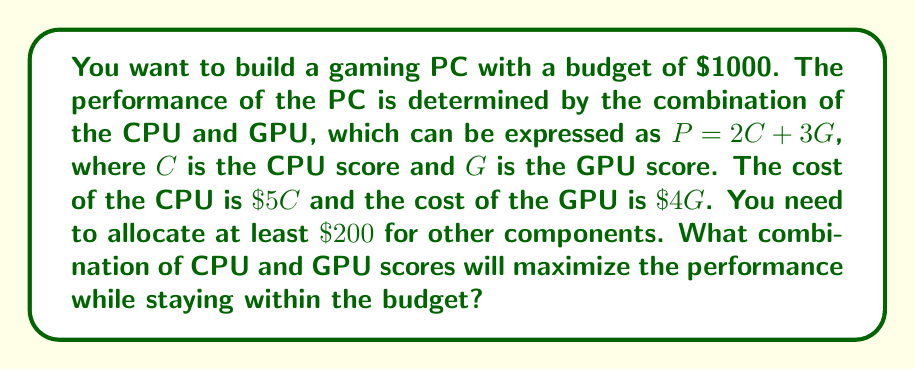Provide a solution to this math problem. Let's approach this step-by-step using linear programming:

1) Define variables:
   $C$ = CPU score
   $G$ = GPU score

2) Objective function (to maximize):
   $P = 2C + 3G$

3) Constraints:
   Budget constraint: $5C + 4G + 200 \leq 1000$
   Non-negativity: $C \geq 0$, $G \geq 0$

4) Simplify the budget constraint:
   $5C + 4G \leq 800$

5) Plot the constraints:
   [asy]
   import graph;
   size(200);
   xaxis("C", 0, 160);
   yaxis("G", 0, 200);
   draw((0,200)--(160,0), blue);
   label("5C + 4G = 800", (80,100), E);
   draw((0,0)--(53.33,100)--(80,100)--(80,0), red);
   label("Feasible Region", (40,50), NW);
   [/asy]

6) The optimal solution will be at one of the corner points. The corners are:
   (0, 200), (160, 0), and the intersection of $5C + 4G = 800$ and $G = 100$

7) Find the intersection point:
   $5C + 4(100) = 800$
   $5C = 400$
   $C = 80$

8) Evaluate the objective function at each corner:
   At (0, 200): $P = 2(0) + 3(200) = 600$
   At (160, 0): $P = 2(160) + 3(0) = 320$
   At (80, 100): $P = 2(80) + 3(100) = 460$

9) The maximum performance is achieved at (0, 200), but this isn't realistic as we need some CPU power. The next best point is (80, 100).

Therefore, the optimal solution is to choose a CPU with a score of 80 and a GPU with a score of 100.
Answer: The optimal combination is a CPU with a score of 80 and a GPU with a score of 100, resulting in a total performance score of 460. 